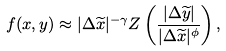Convert formula to latex. <formula><loc_0><loc_0><loc_500><loc_500>f ( x , y ) \approx | \Delta \widetilde { x } | ^ { - \gamma } Z \left ( \frac { | \Delta \widetilde { y } | } { | \Delta \widetilde { x } | ^ { \phi } } \right ) ,</formula> 